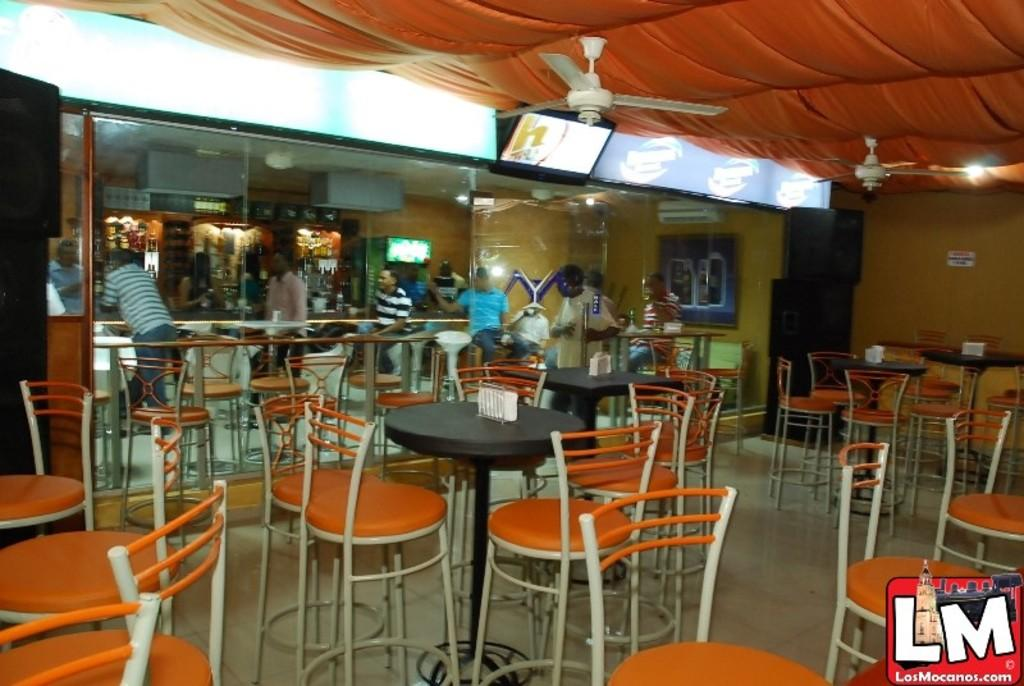What type of establishment is shown in the image? There is a restaurant in the image. Who is present in the image? There is a group of people in the image. What is a piece of furniture that can be seen in the image? There is a table in the image. What item is placed on the table? There is a tissue on the table. What elements can be seen in the background of the image? In the background, there is a curtain, a television, a fan, and a window. What type of potato is being used as a decoration on the table? There is no potato present in the image, let alone one being used as a decoration. 